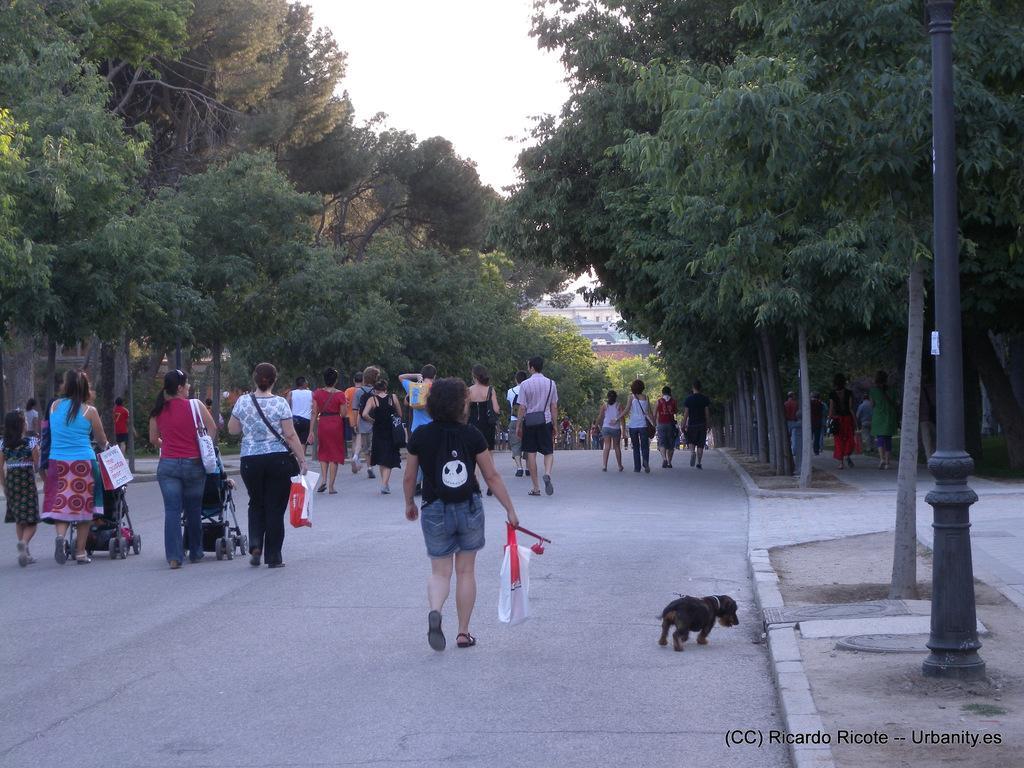In one or two sentences, can you explain what this image depicts? In the middle of the image few people are walking and holding some bags and strollers and we can see a dog. In front of them we can see some poles, trees and buildings. At the top of the image we can see the sky. 